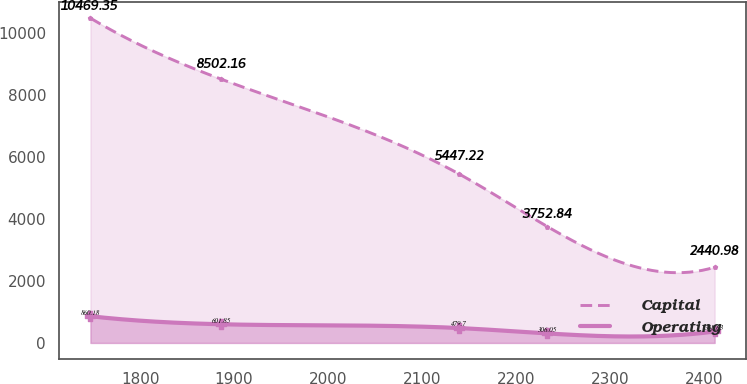<chart> <loc_0><loc_0><loc_500><loc_500><line_chart><ecel><fcel>Capital<fcel>Operating<nl><fcel>1747.11<fcel>10469.4<fcel>860.18<nl><fcel>1886.29<fcel>8502.16<fcel>601.85<nl><fcel>2139.4<fcel>5447.22<fcel>479.7<nl><fcel>2233.27<fcel>3752.84<fcel>306.05<nl><fcel>2411.45<fcel>2440.98<fcel>368.63<nl></chart> 